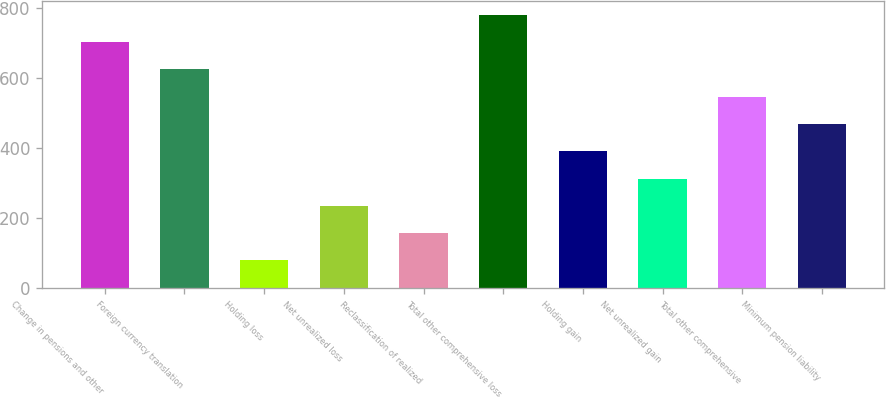Convert chart. <chart><loc_0><loc_0><loc_500><loc_500><bar_chart><fcel>Change in pensions and other<fcel>Foreign currency translation<fcel>Holding loss<fcel>Net unrealized loss<fcel>Reclassification of realized<fcel>Total other comprehensive loss<fcel>Holding gain<fcel>Net unrealized gain<fcel>Total other comprehensive<fcel>Minimum pension liability<nl><fcel>703<fcel>625<fcel>79<fcel>235<fcel>157<fcel>781<fcel>391<fcel>313<fcel>547<fcel>469<nl></chart> 